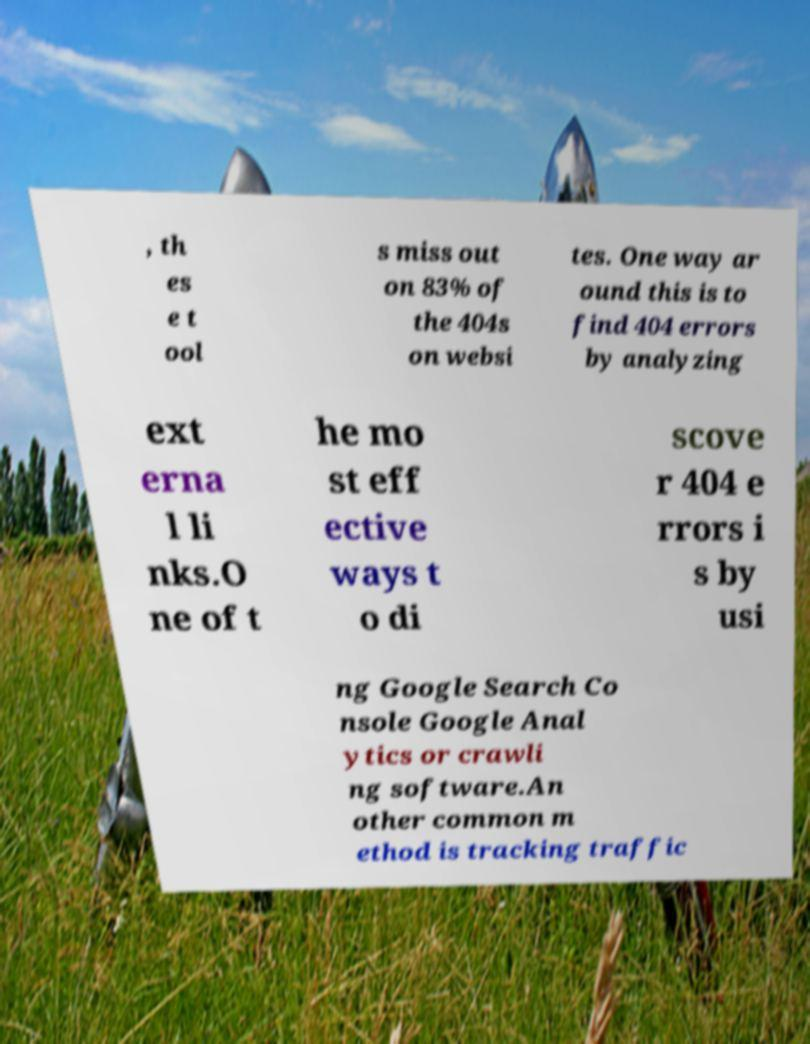Could you extract and type out the text from this image? , th es e t ool s miss out on 83% of the 404s on websi tes. One way ar ound this is to find 404 errors by analyzing ext erna l li nks.O ne of t he mo st eff ective ways t o di scove r 404 e rrors i s by usi ng Google Search Co nsole Google Anal ytics or crawli ng software.An other common m ethod is tracking traffic 